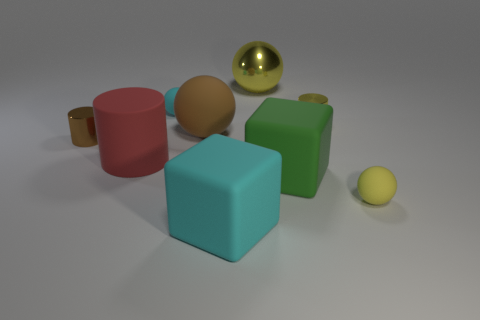Add 1 tiny gray cylinders. How many objects exist? 10 Subtract all balls. How many objects are left? 5 Add 1 tiny spheres. How many tiny spheres exist? 3 Subtract 0 red balls. How many objects are left? 9 Subtract all big objects. Subtract all big cyan metallic blocks. How many objects are left? 4 Add 5 large brown spheres. How many large brown spheres are left? 6 